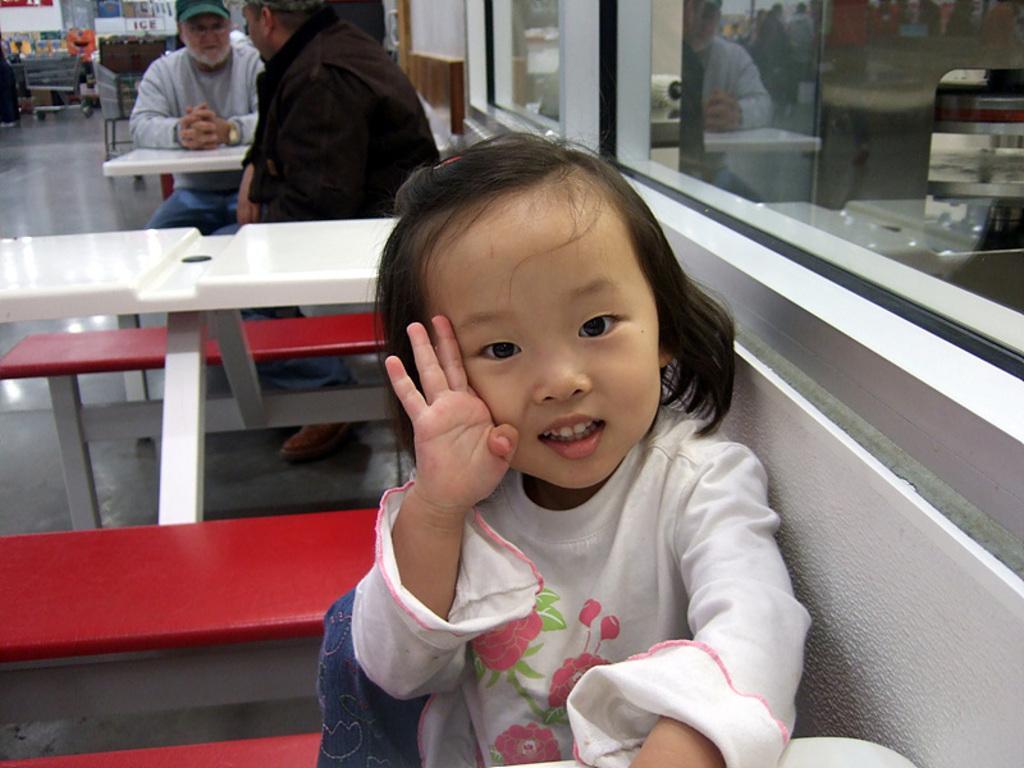In one or two sentences, can you explain what this image depicts? This kid is highlighted in this picture. This kid is sitting on a bench. We can able to see a persons are sitting on a bench. In-front of this person there is a table. Far there are carts. This is a glass window. 